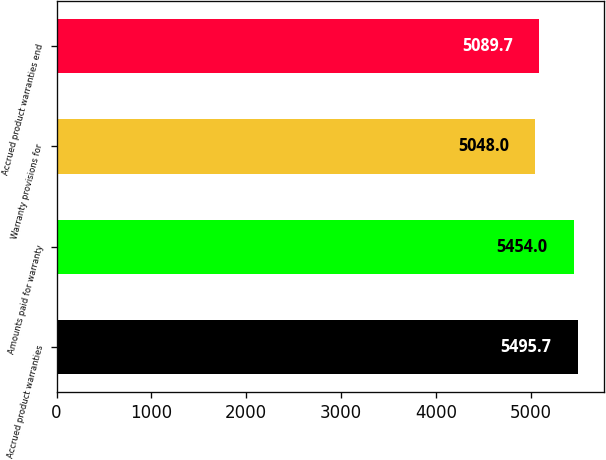Convert chart to OTSL. <chart><loc_0><loc_0><loc_500><loc_500><bar_chart><fcel>Accrued product warranties<fcel>Amounts paid for warranty<fcel>Warranty provisions for<fcel>Accrued product warranties end<nl><fcel>5495.7<fcel>5454<fcel>5048<fcel>5089.7<nl></chart> 